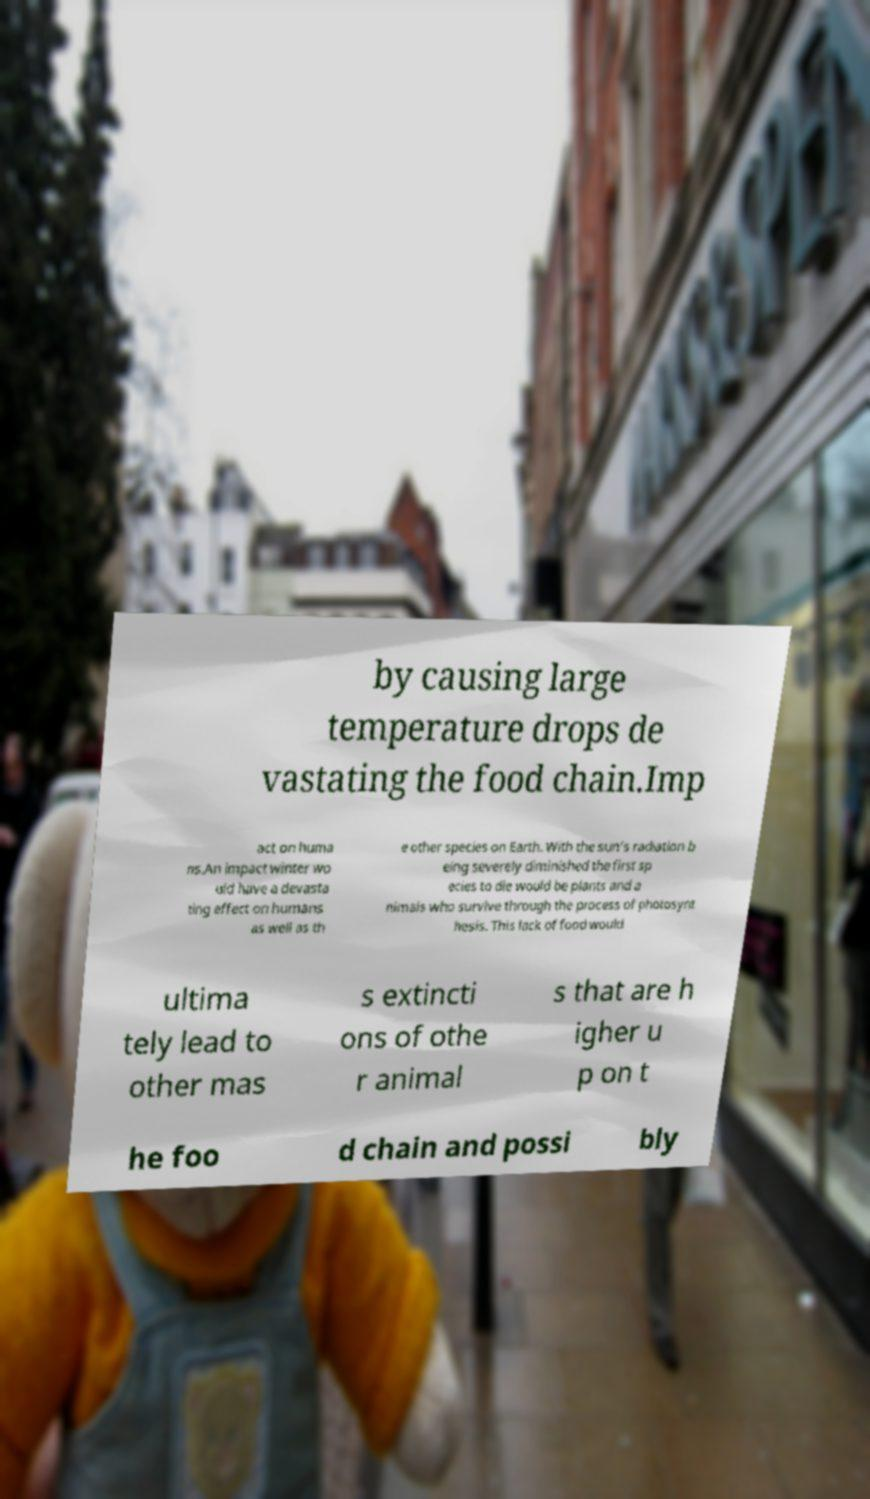For documentation purposes, I need the text within this image transcribed. Could you provide that? by causing large temperature drops de vastating the food chain.Imp act on huma ns.An impact winter wo uld have a devasta ting effect on humans as well as th e other species on Earth. With the sun's radiation b eing severely diminished the first sp ecies to die would be plants and a nimals who survive through the process of photosynt hesis. This lack of food would ultima tely lead to other mas s extincti ons of othe r animal s that are h igher u p on t he foo d chain and possi bly 